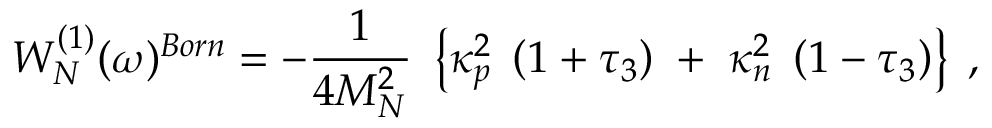<formula> <loc_0><loc_0><loc_500><loc_500>W _ { N } ^ { ( 1 ) } ( \omega ) ^ { B o r n } = - \frac { 1 } { 4 M _ { N } ^ { 2 } } \, \left \{ \kappa _ { p } ^ { 2 } \, \left ( 1 + \tau _ { 3 } \right ) \, + \, \kappa _ { n } ^ { 2 } \, \left ( 1 - \tau _ { 3 } \right ) \right \} \, ,</formula> 